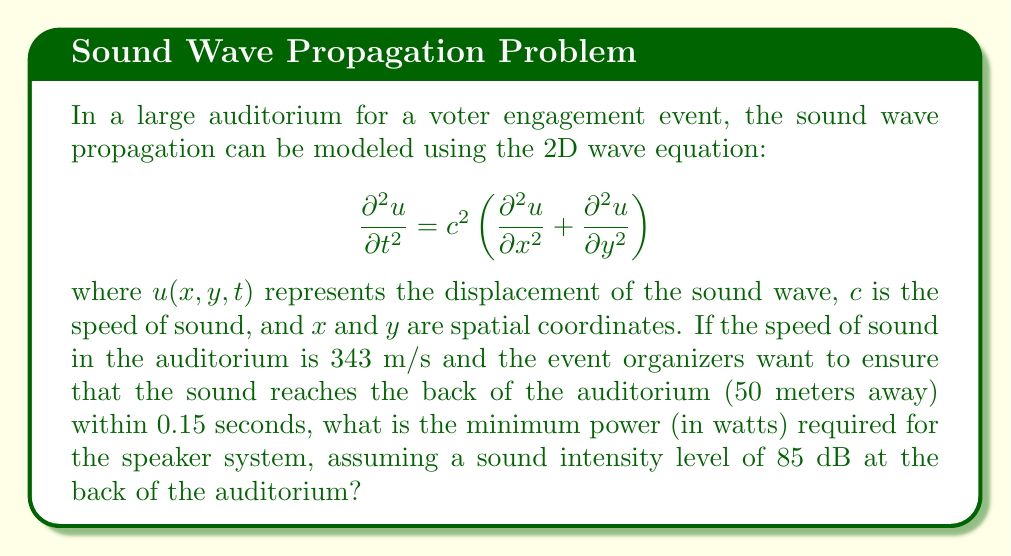Give your solution to this math problem. Let's approach this step-by-step:

1) First, we need to verify if the sound can reach the back of the auditorium in 0.15 seconds:
   Distance = 50 m
   Time = 0.15 s
   Speed of sound = 343 m/s
   
   $50 \text{ m} < 343 \text{ m/s} \times 0.15 \text{ s} = 51.45 \text{ m}$
   
   So, yes, the sound can reach the back in 0.15 seconds.

2) Now, we need to calculate the sound intensity at the back of the auditorium:
   $I = I_0 \times 10^{\frac{L}{10}}$
   where $I_0 = 10^{-12} \text{ W/m}^2$ (reference intensity) and $L = 85 \text{ dB}$

   $I = 10^{-12} \times 10^{\frac{85}{10}} = 3.16 \times 10^{-4} \text{ W/m}^2$

3) To find the power, we need to consider the surface area of a sphere with radius 50 m:
   $A = 4\pi r^2 = 4\pi (50)^2 = 31,415.93 \text{ m}^2$

4) The power is then calculated as:
   $P = I \times A = 3.16 \times 10^{-4} \text{ W/m}^2 \times 31,415.93 \text{ m}^2 = 9.93 \text{ W}$

5) Rounding up to ensure minimum power requirement is met:
   Minimum power required ≈ 10 W
Answer: 10 W 